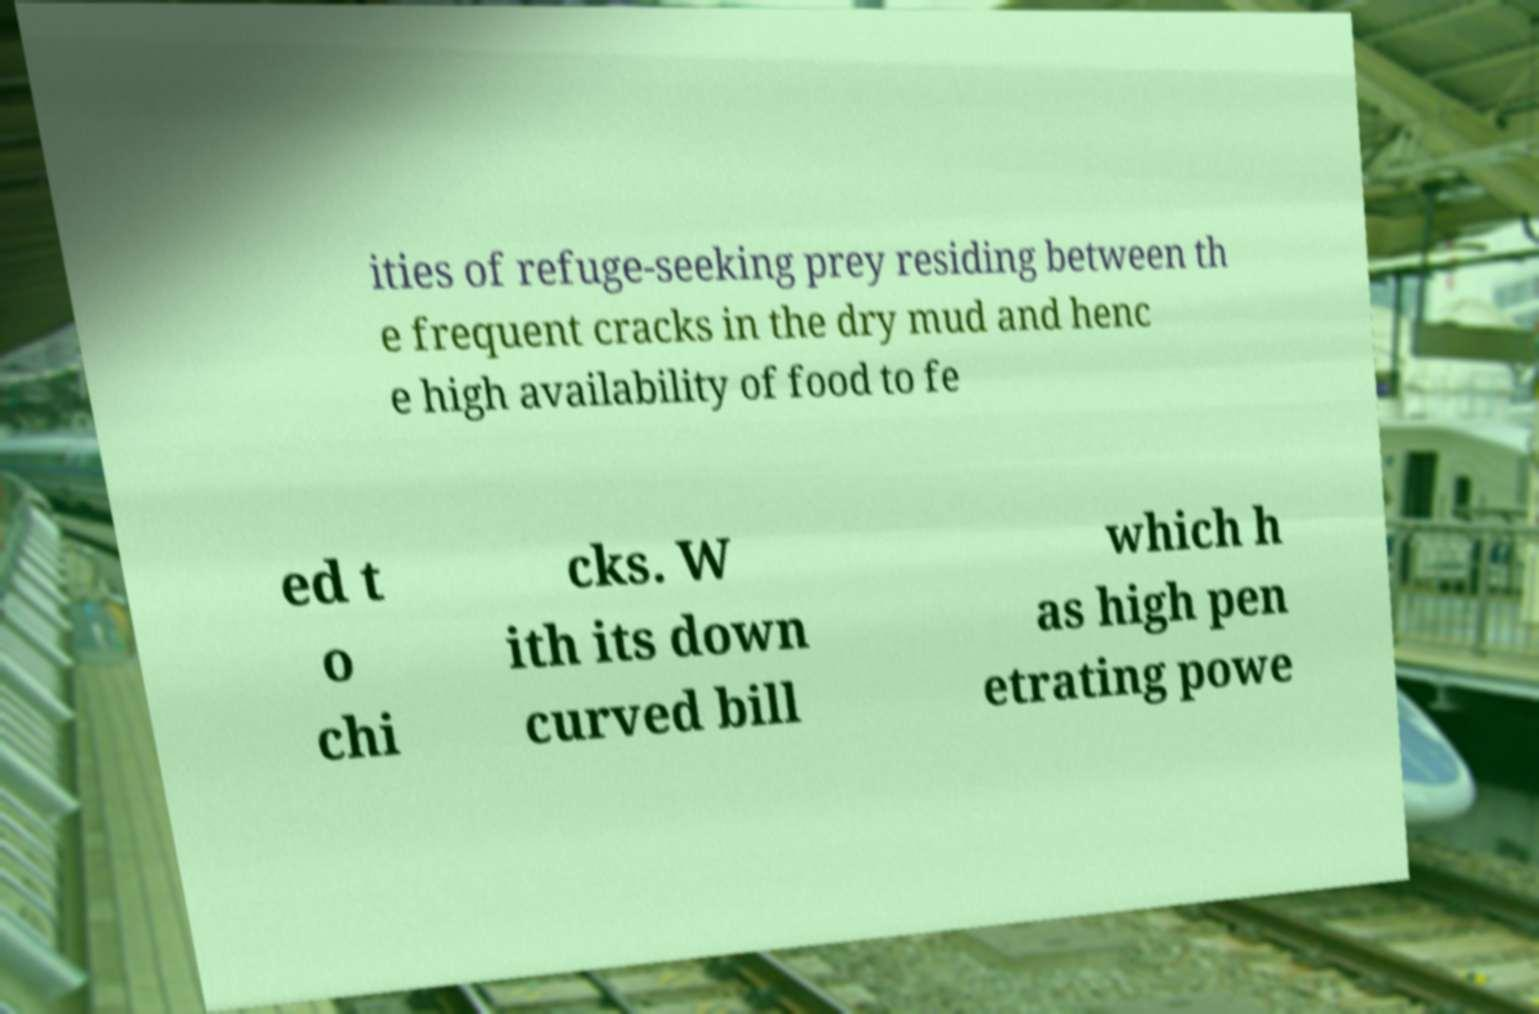Can you accurately transcribe the text from the provided image for me? ities of refuge-seeking prey residing between th e frequent cracks in the dry mud and henc e high availability of food to fe ed t o chi cks. W ith its down curved bill which h as high pen etrating powe 